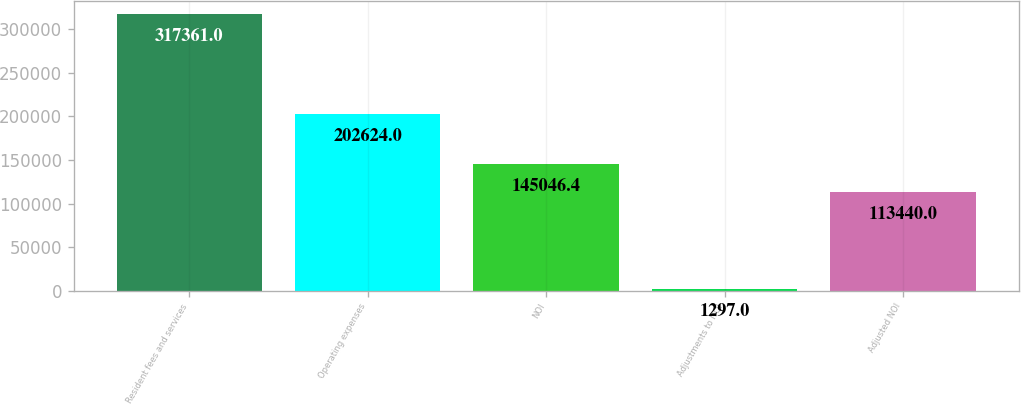<chart> <loc_0><loc_0><loc_500><loc_500><bar_chart><fcel>Resident fees and services<fcel>Operating expenses<fcel>NOI<fcel>Adjustments to NOI<fcel>Adjusted NOI<nl><fcel>317361<fcel>202624<fcel>145046<fcel>1297<fcel>113440<nl></chart> 